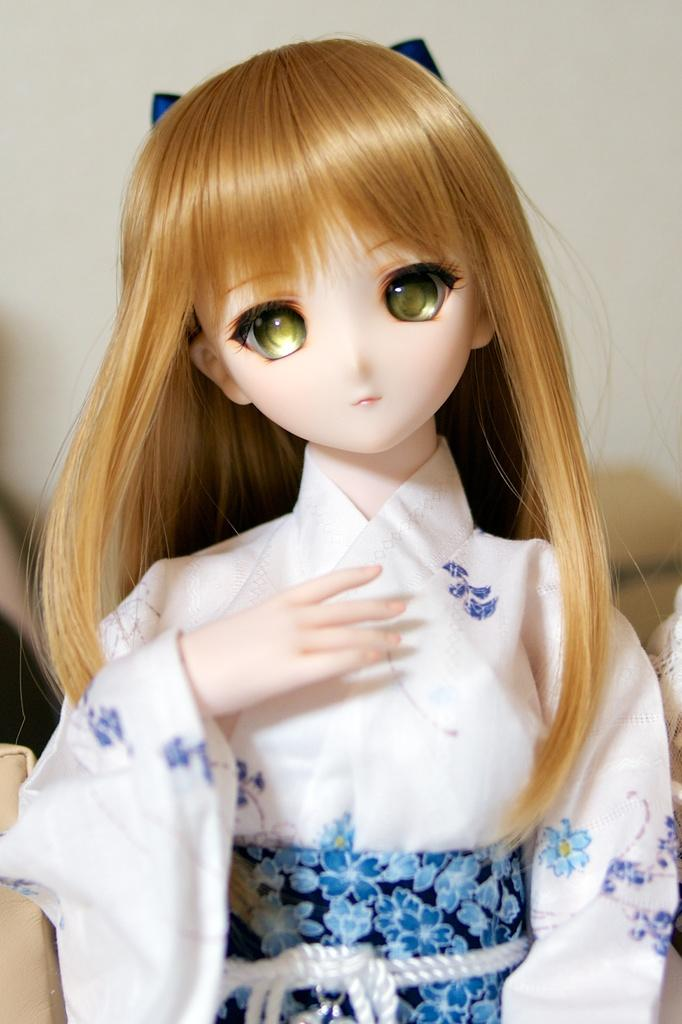What is the main subject in the image? There is a doll in the image. What else can be seen in the image besides the doll? There are some objects in the image. Can you describe the background of the image? The background of the image appears blurry. What type of screw is holding the vase together in the image? There is no screw or vase present in the image; it only features a doll and some objects. 